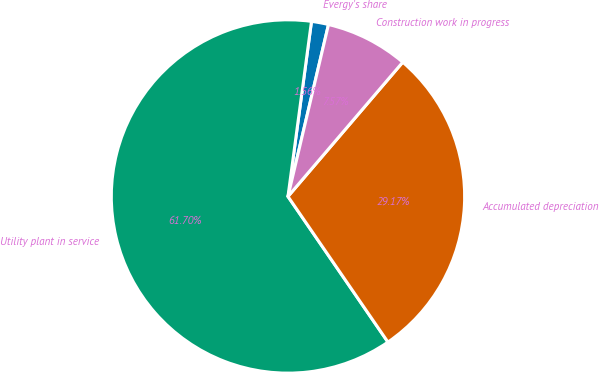Convert chart to OTSL. <chart><loc_0><loc_0><loc_500><loc_500><pie_chart><fcel>Evergy's share<fcel>Utility plant in service<fcel>Accumulated depreciation<fcel>Construction work in progress<nl><fcel>1.56%<fcel>61.7%<fcel>29.17%<fcel>7.57%<nl></chart> 